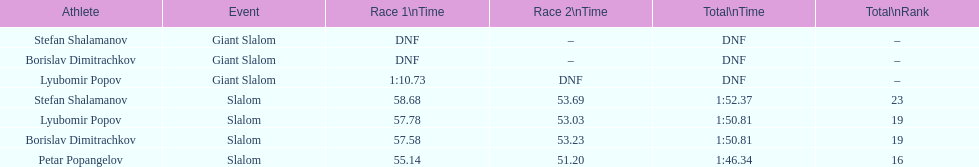What is the total of athletes that finished race one in the giant slalom? 1. 